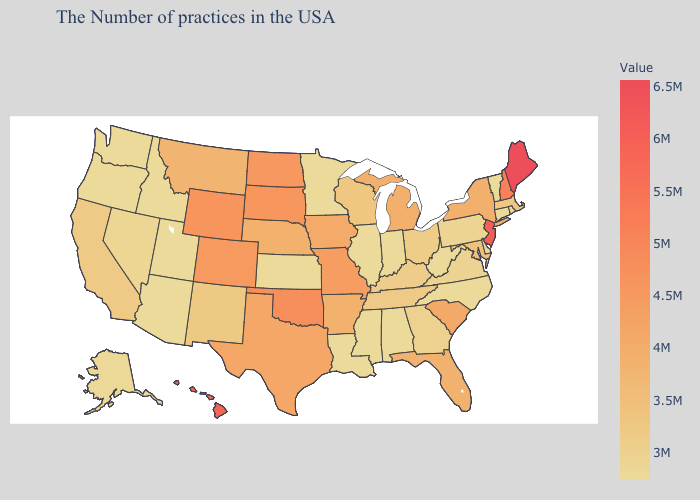Which states hav the highest value in the Northeast?
Be succinct. Maine. Does Maine have the highest value in the USA?
Give a very brief answer. Yes. Which states have the lowest value in the USA?
Give a very brief answer. Rhode Island, Vermont, Connecticut, North Carolina, West Virginia, Indiana, Alabama, Illinois, Mississippi, Louisiana, Minnesota, Kansas, Utah, Arizona, Idaho, Washington, Oregon. Does Illinois have the lowest value in the USA?
Quick response, please. Yes. 